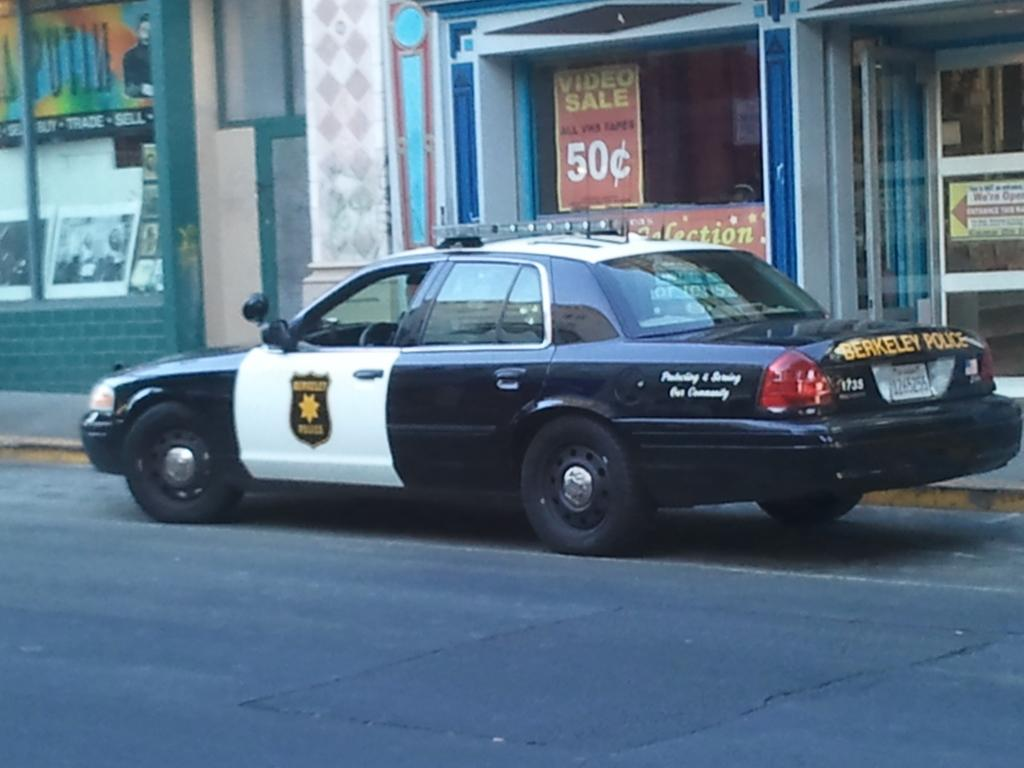<image>
Describe the image concisely. A Berkeley police cruiser is parked by the curb in front of a store. 